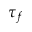Convert formula to latex. <formula><loc_0><loc_0><loc_500><loc_500>\tau _ { f }</formula> 